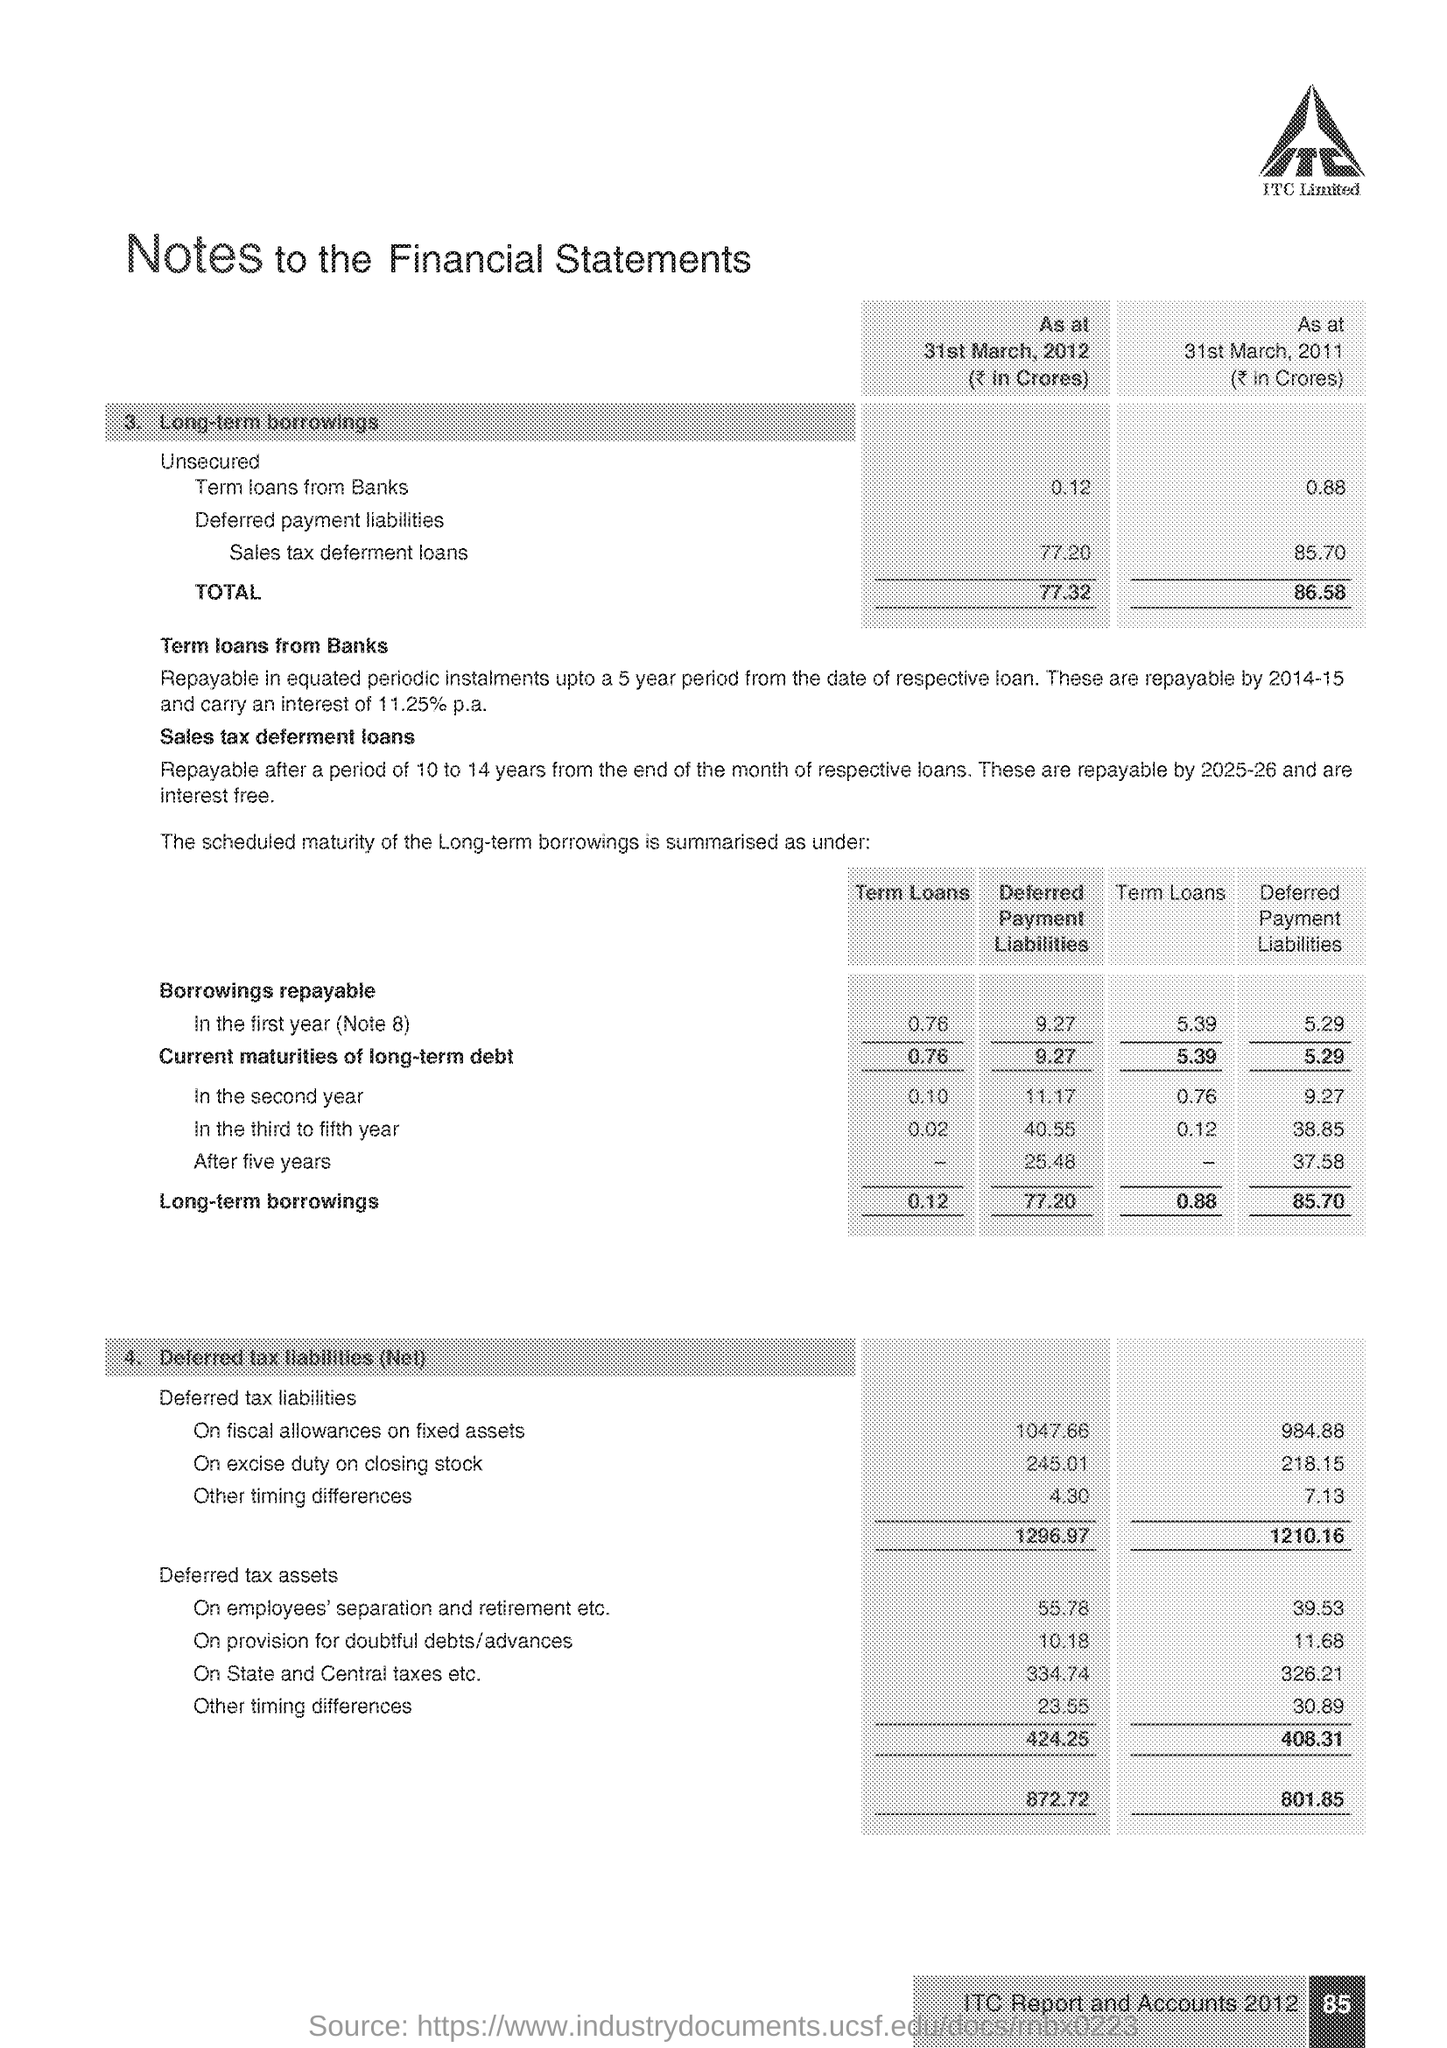Mention a couple of crucial points in this snapshot. As of March 31, 2012, the total amount of long-term borrowings was approximately Rs. 0.12. As of March 31st, 2011, the total of long-term borrowings was 86.58. 